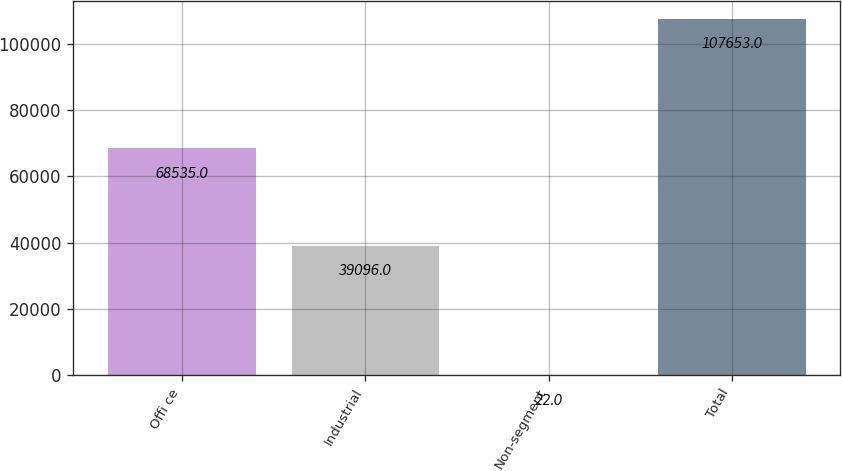<chart> <loc_0><loc_0><loc_500><loc_500><bar_chart><fcel>Offi ce<fcel>Industrial<fcel>Non-segment<fcel>Total<nl><fcel>68535<fcel>39096<fcel>22<fcel>107653<nl></chart> 